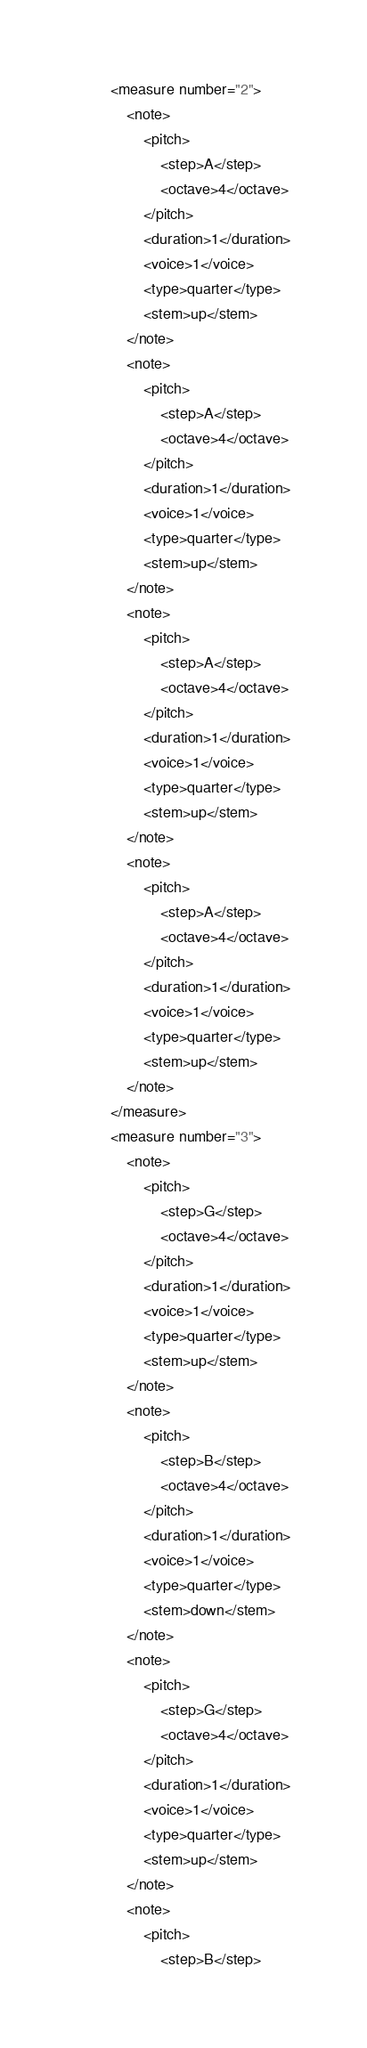<code> <loc_0><loc_0><loc_500><loc_500><_XML_>		<measure number="2">
			<note>
				<pitch>
					<step>A</step>
					<octave>4</octave>
				</pitch>
				<duration>1</duration>
				<voice>1</voice>
				<type>quarter</type>
				<stem>up</stem>
			</note>
			<note>
				<pitch>
					<step>A</step>
					<octave>4</octave>
				</pitch>
				<duration>1</duration>
				<voice>1</voice>
				<type>quarter</type>
				<stem>up</stem>
			</note>
			<note>
				<pitch>
					<step>A</step>
					<octave>4</octave>
				</pitch>
				<duration>1</duration>
				<voice>1</voice>
				<type>quarter</type>
				<stem>up</stem>
			</note>
			<note>
				<pitch>
					<step>A</step>
					<octave>4</octave>
				</pitch>
				<duration>1</duration>
				<voice>1</voice>
				<type>quarter</type>
				<stem>up</stem>
			</note>
		</measure>
		<measure number="3">
			<note>
				<pitch>
					<step>G</step>
					<octave>4</octave>
				</pitch>
				<duration>1</duration>
				<voice>1</voice>
				<type>quarter</type>
				<stem>up</stem>
			</note>
			<note>
				<pitch>
					<step>B</step>
					<octave>4</octave>
				</pitch>
				<duration>1</duration>
				<voice>1</voice>
				<type>quarter</type>
				<stem>down</stem>
			</note>
			<note>
				<pitch>
					<step>G</step>
					<octave>4</octave>
				</pitch>
				<duration>1</duration>
				<voice>1</voice>
				<type>quarter</type>
				<stem>up</stem>
			</note>
			<note>
				<pitch>
					<step>B</step></code> 